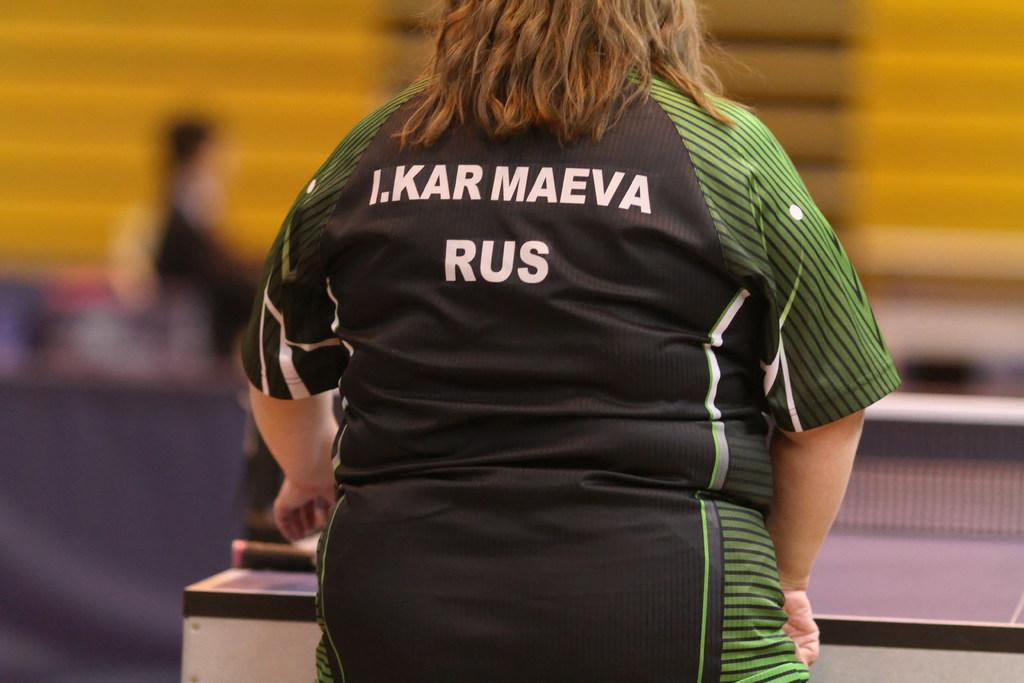<image>
Summarize the visual content of the image. the letters RUS are on the back of the shirt 